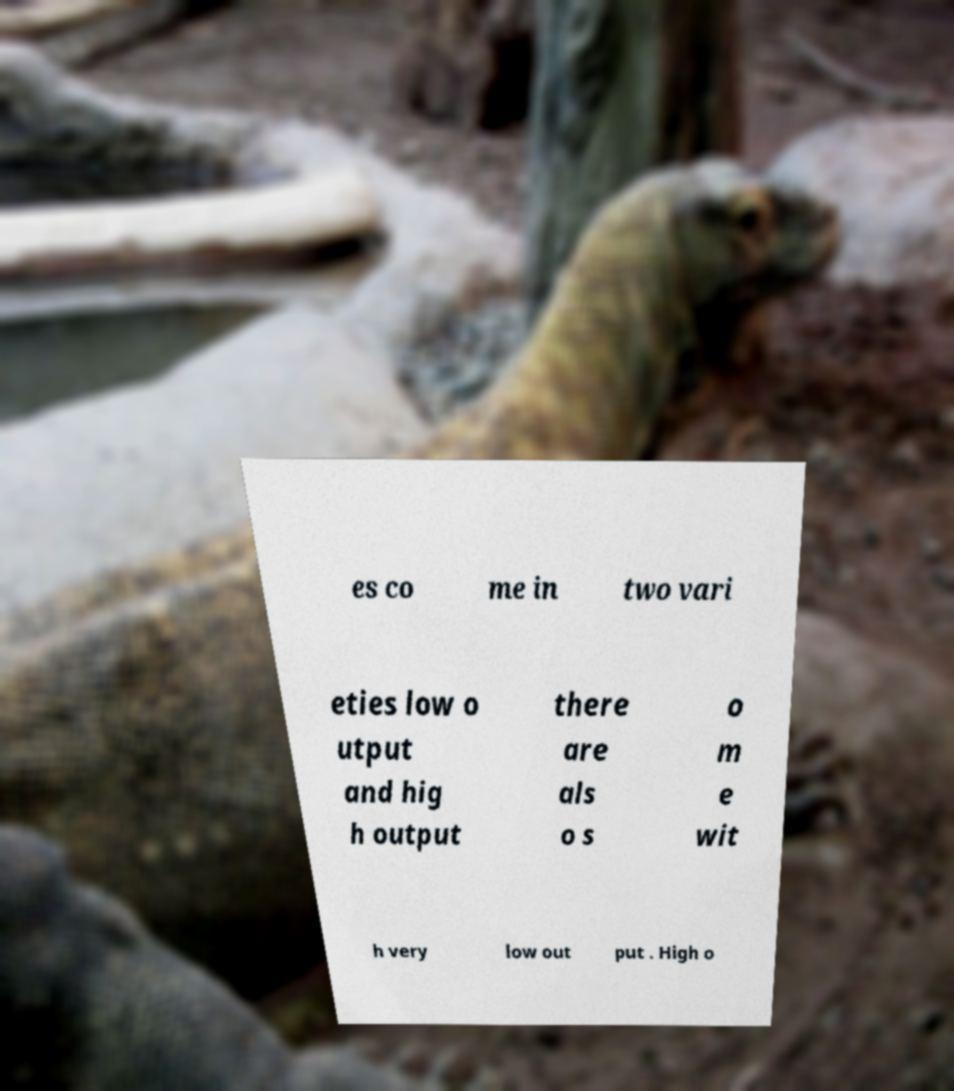Could you extract and type out the text from this image? es co me in two vari eties low o utput and hig h output there are als o s o m e wit h very low out put . High o 